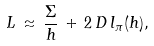Convert formula to latex. <formula><loc_0><loc_0><loc_500><loc_500>L \, \approx \, \frac { \Sigma } { h } \, + \, 2 \, D \, l _ { \pi } ( h ) ,</formula> 